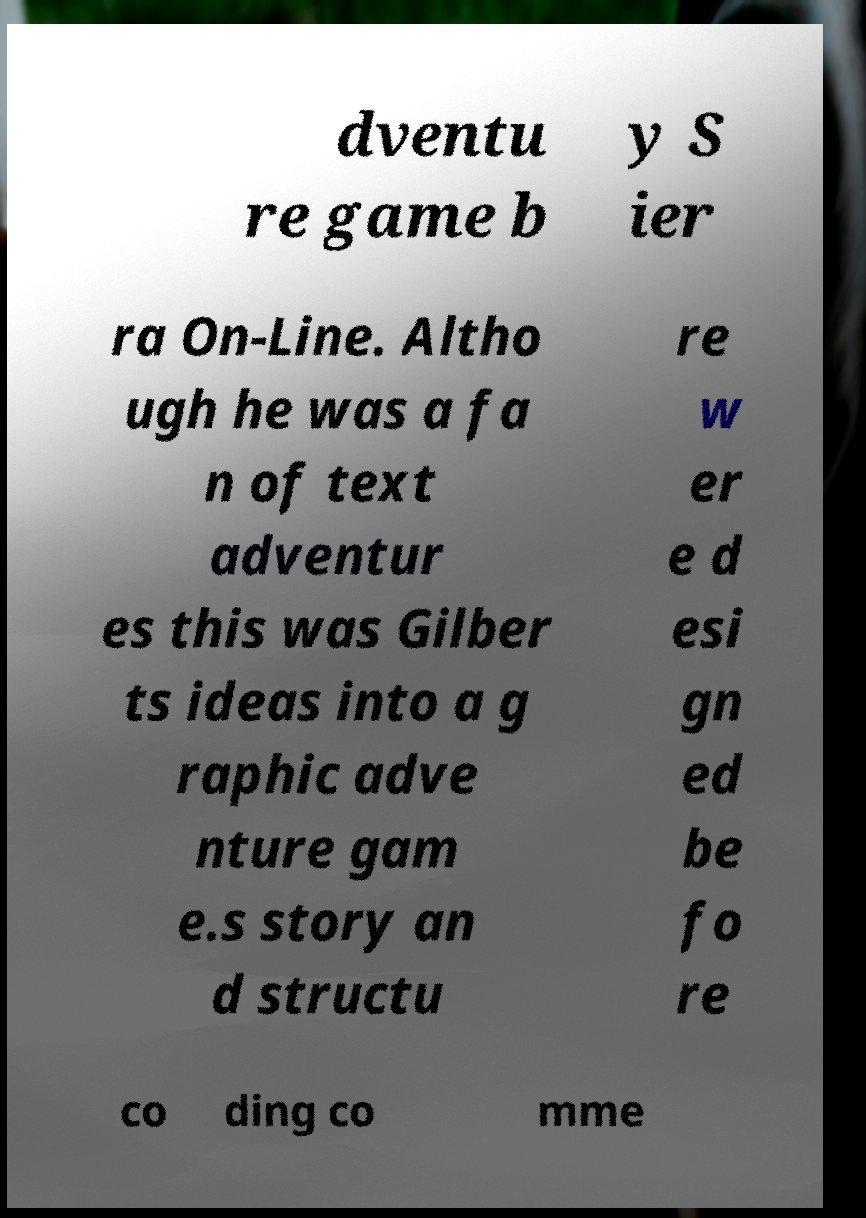I need the written content from this picture converted into text. Can you do that? dventu re game b y S ier ra On-Line. Altho ugh he was a fa n of text adventur es this was Gilber ts ideas into a g raphic adve nture gam e.s story an d structu re w er e d esi gn ed be fo re co ding co mme 